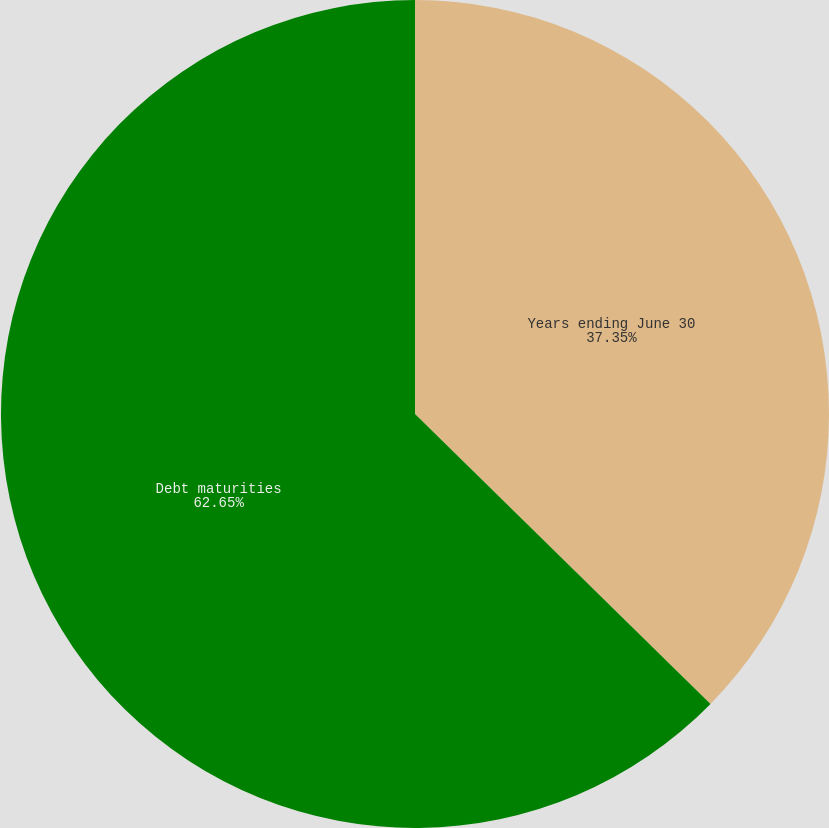<chart> <loc_0><loc_0><loc_500><loc_500><pie_chart><fcel>Years ending June 30<fcel>Debt maturities<nl><fcel>37.35%<fcel>62.65%<nl></chart> 